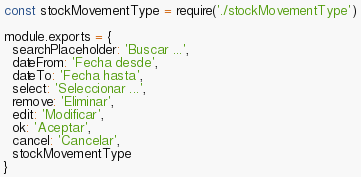Convert code to text. <code><loc_0><loc_0><loc_500><loc_500><_JavaScript_>const stockMovementType = require('./stockMovementType')

module.exports = {
  searchPlaceholder: 'Buscar ...',
  dateFrom: 'Fecha desde',
  dateTo: 'Fecha hasta',
  select: 'Seleccionar ...',
  remove: 'Eliminar',
  edit: 'Modificar',
  ok: 'Aceptar',
  cancel: 'Cancelar',
  stockMovementType
}
</code> 